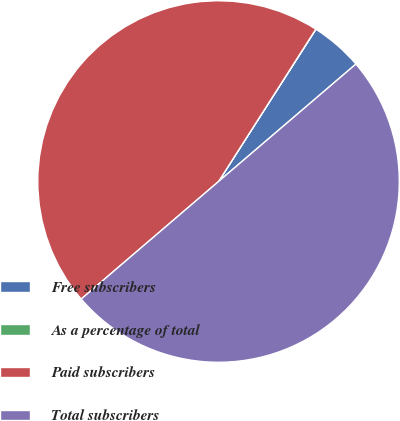Convert chart to OTSL. <chart><loc_0><loc_0><loc_500><loc_500><pie_chart><fcel>Free subscribers<fcel>As a percentage of total<fcel>Paid subscribers<fcel>Total subscribers<nl><fcel>4.69%<fcel>0.01%<fcel>45.31%<fcel>49.99%<nl></chart> 